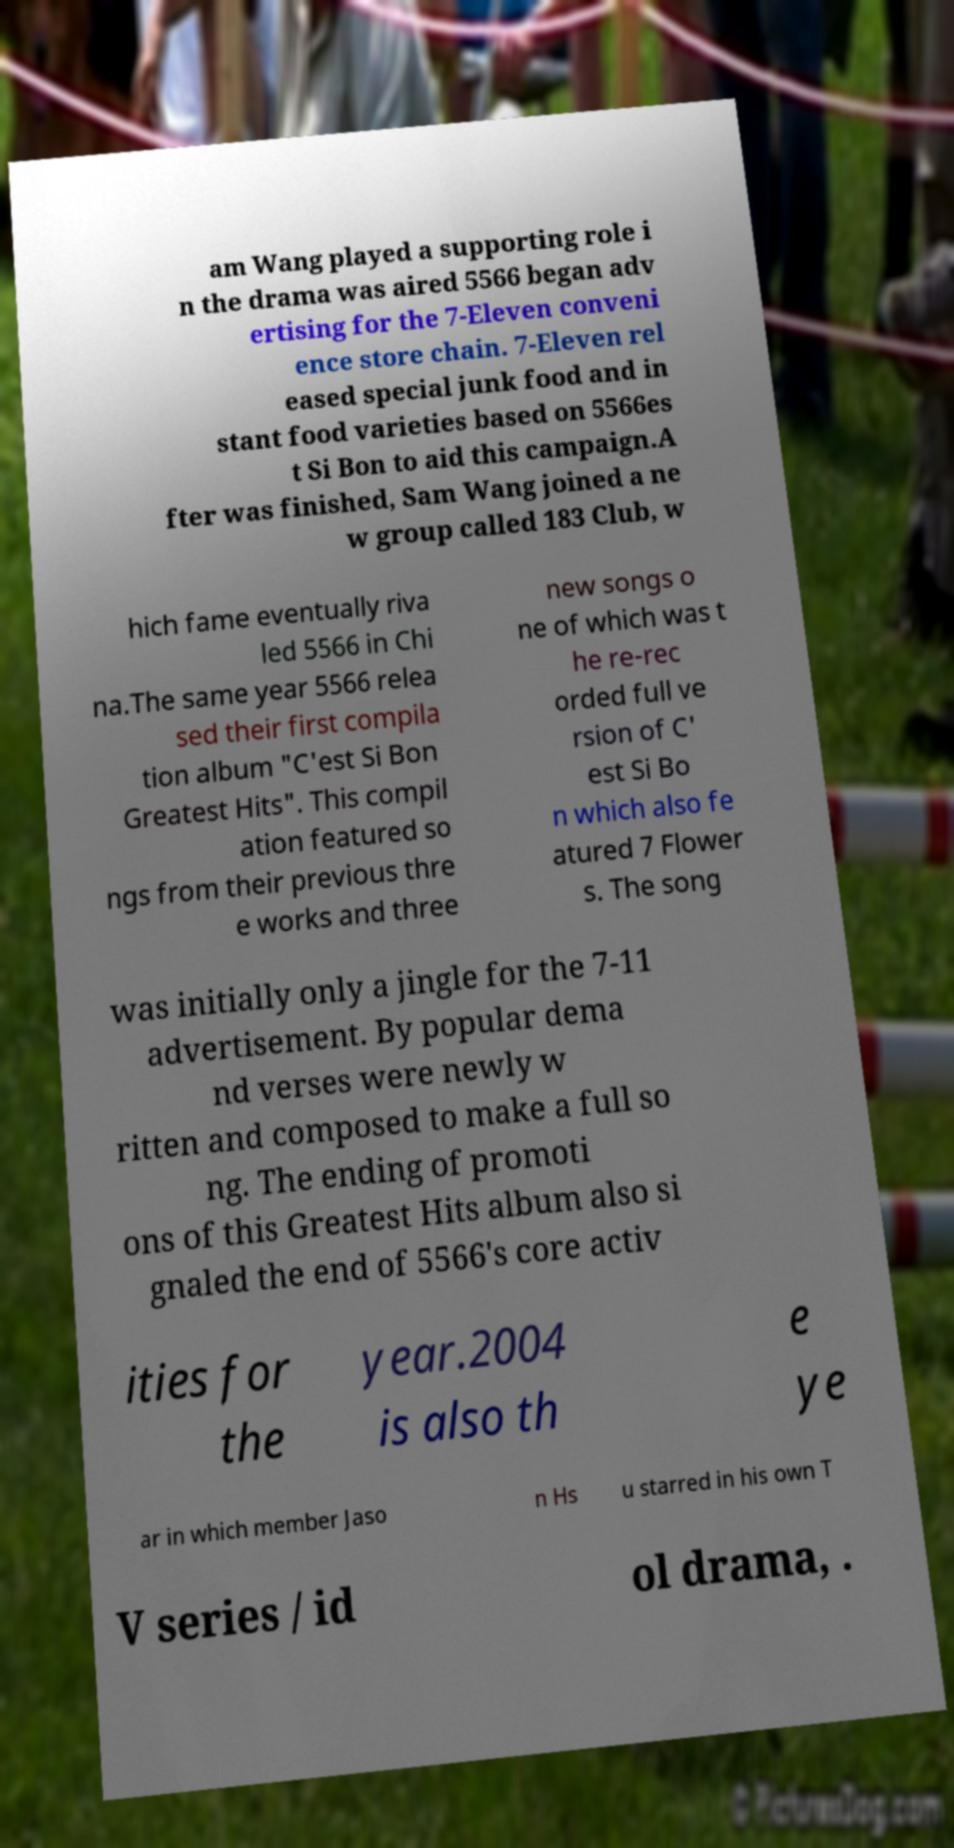Please identify and transcribe the text found in this image. am Wang played a supporting role i n the drama was aired 5566 began adv ertising for the 7-Eleven conveni ence store chain. 7-Eleven rel eased special junk food and in stant food varieties based on 5566es t Si Bon to aid this campaign.A fter was finished, Sam Wang joined a ne w group called 183 Club, w hich fame eventually riva led 5566 in Chi na.The same year 5566 relea sed their first compila tion album "C'est Si Bon Greatest Hits". This compil ation featured so ngs from their previous thre e works and three new songs o ne of which was t he re-rec orded full ve rsion of C' est Si Bo n which also fe atured 7 Flower s. The song was initially only a jingle for the 7-11 advertisement. By popular dema nd verses were newly w ritten and composed to make a full so ng. The ending of promoti ons of this Greatest Hits album also si gnaled the end of 5566's core activ ities for the year.2004 is also th e ye ar in which member Jaso n Hs u starred in his own T V series / id ol drama, . 